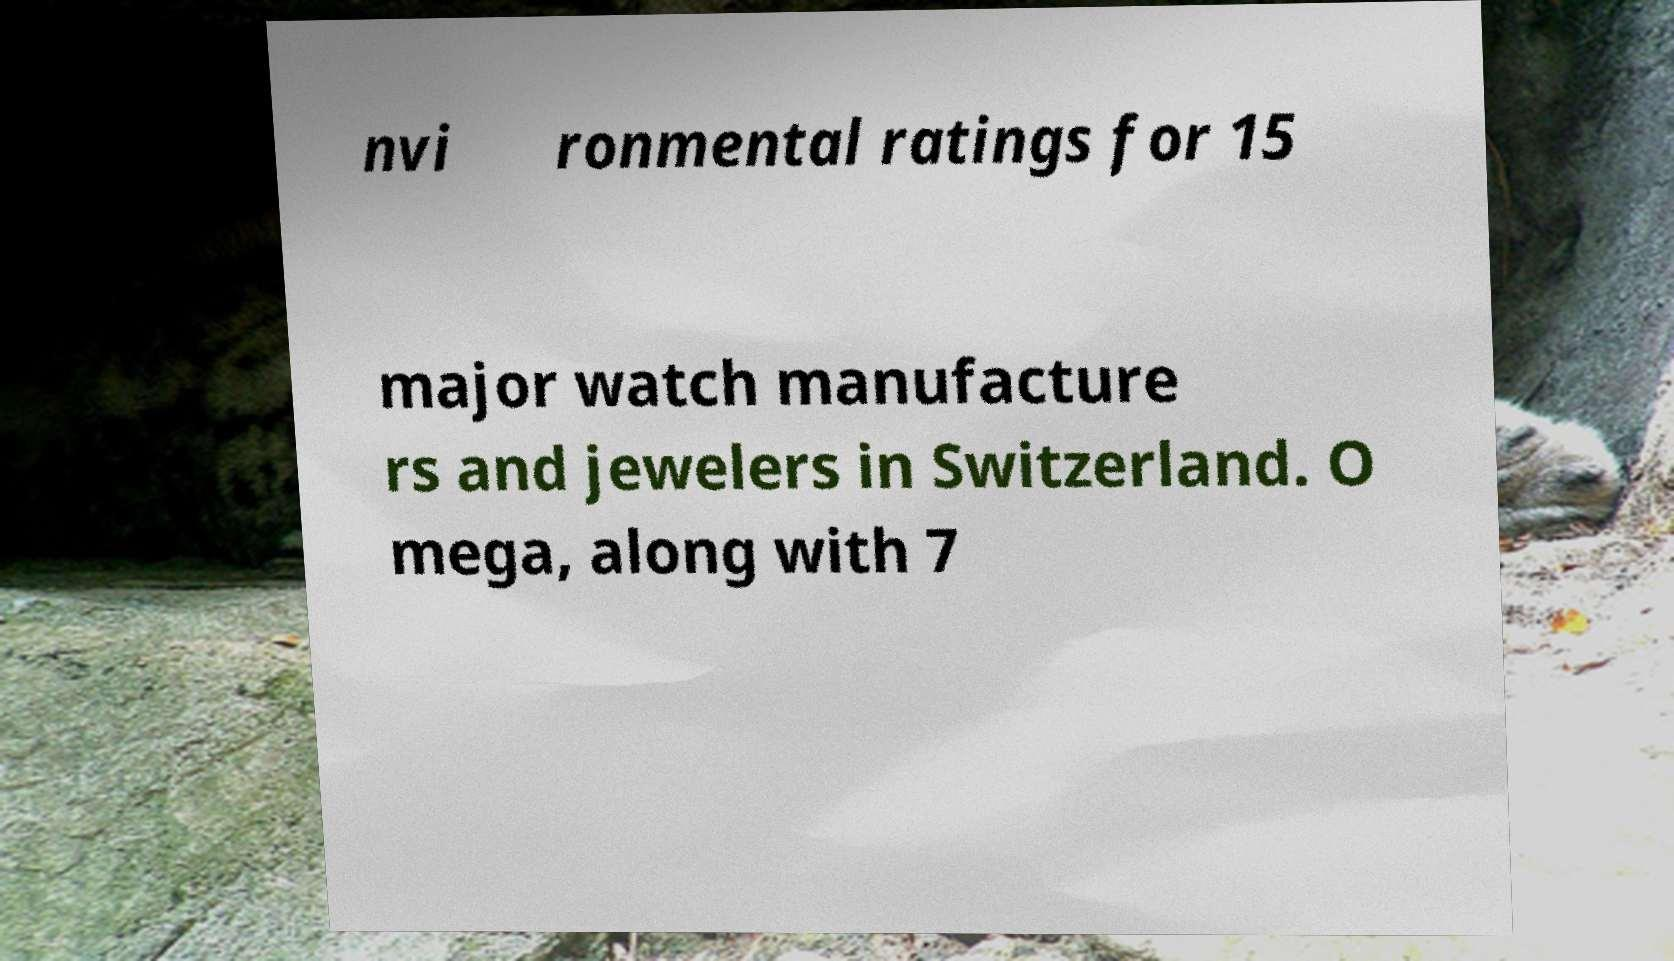Please identify and transcribe the text found in this image. nvi ronmental ratings for 15 major watch manufacture rs and jewelers in Switzerland. O mega, along with 7 